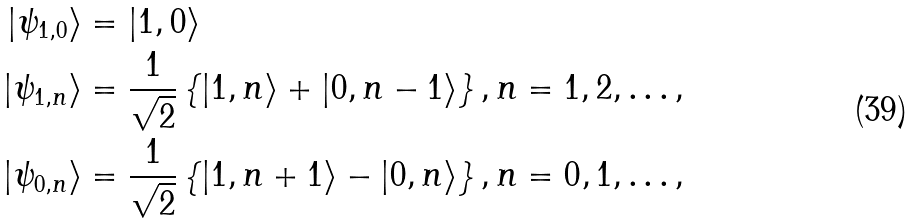<formula> <loc_0><loc_0><loc_500><loc_500>| \psi _ { 1 , 0 } \rangle & = | 1 , 0 \rangle \\ | \psi _ { 1 , n } \rangle & = \frac { 1 } { \sqrt { 2 } } \left \{ | 1 , n \rangle + | 0 , n - 1 \rangle \right \} , n = 1 , 2 , \dots , \\ | \psi _ { 0 , n } \rangle & = \frac { 1 } { \sqrt { 2 } } \left \{ | 1 , n + 1 \rangle - | 0 , n \rangle \right \} , n = 0 , 1 , \dots ,</formula> 